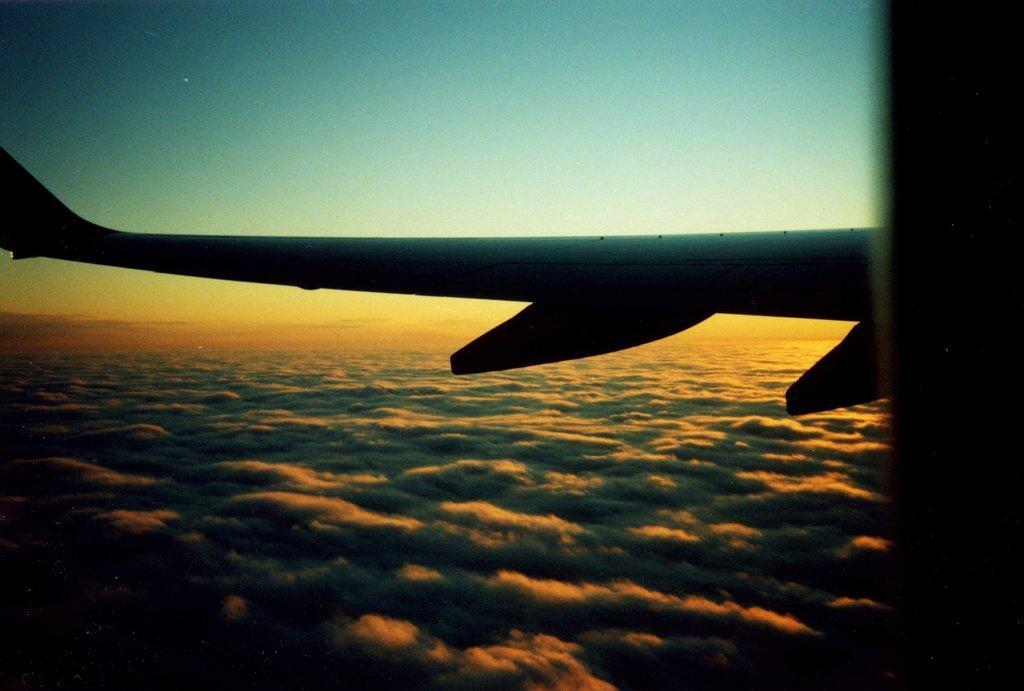Please provide a concise description of this image. In this image I can see a part of an aeroplane. At the top, I can see the sky. 